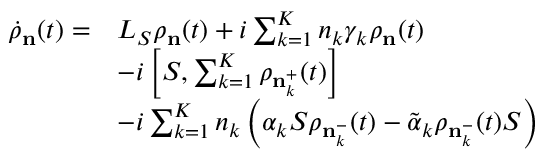<formula> <loc_0><loc_0><loc_500><loc_500>\begin{array} { r l } { { { { \dot { \rho } } } _ { n } } ( t ) = } & { { { L } _ { S } } { { \rho } _ { n } } ( t ) + i \sum _ { k = 1 } ^ { K } { { { n } _ { k } } { { \gamma } _ { k } } { { \rho } _ { n } } } ( t ) } \\ & { - i \left [ S , \sum _ { k = 1 } ^ { K } { { { \rho } _ { n _ { k } ^ { + } } } ( t ) } \right ] } \\ & { - i \sum _ { k = 1 } ^ { K } { { { n } _ { k } } \left ( { { \alpha } _ { k } } { S } { { \rho } _ { n _ { k } ^ { - } } } ( t ) - { { { \tilde { \alpha } } } _ { k } } { { \rho } _ { n _ { k } ^ { - } } } ( t ) S \right ) } } \end{array}</formula> 